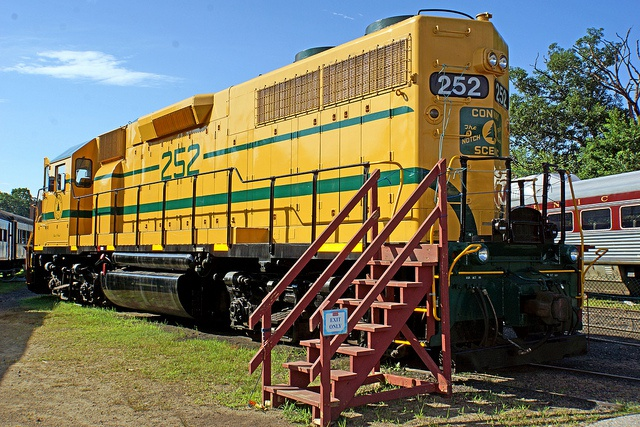Describe the objects in this image and their specific colors. I can see train in lightblue, black, olive, gold, and orange tones, train in lightblue, black, lightgray, and darkgray tones, and train in lightblue, black, darkgray, and gray tones in this image. 